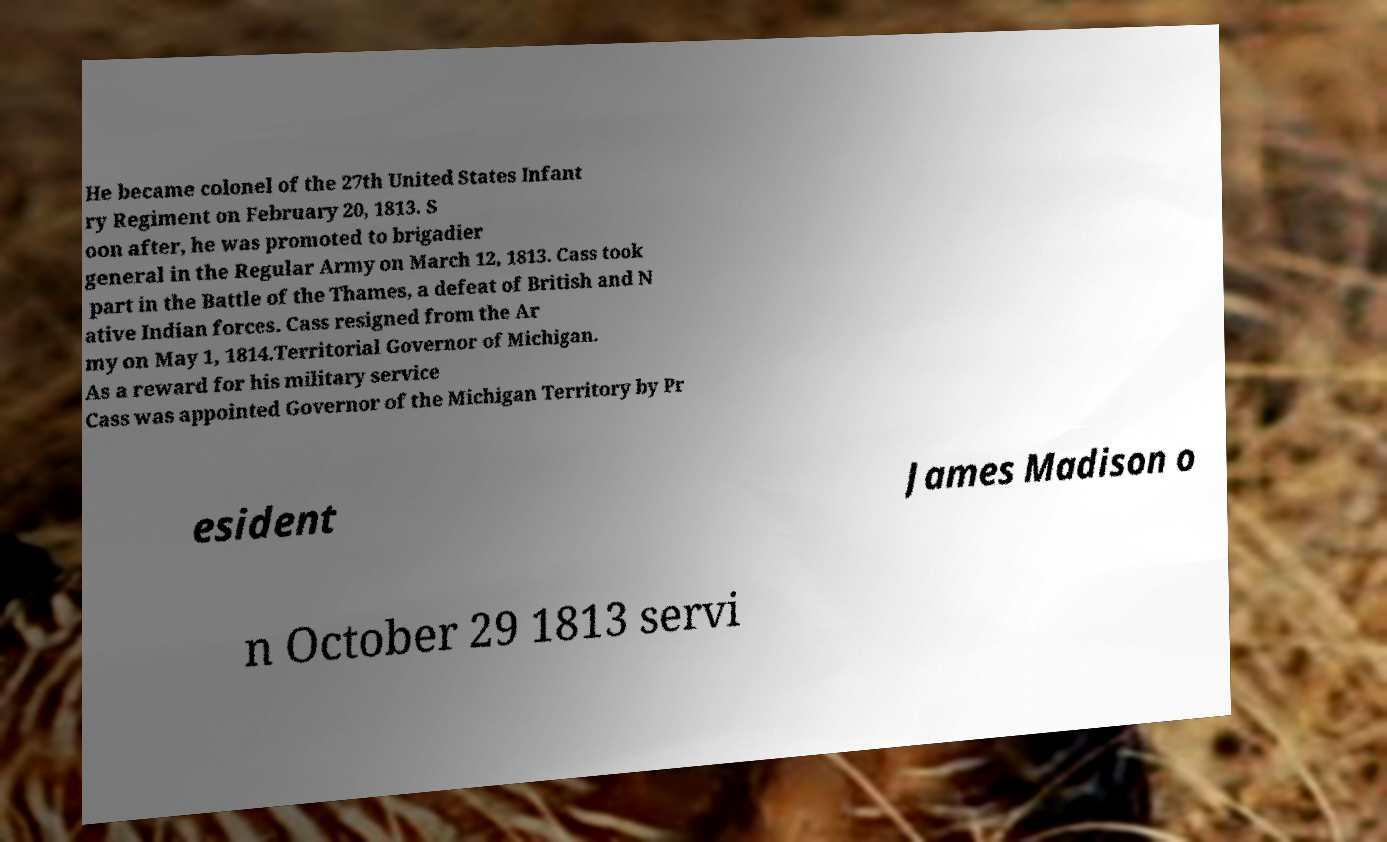I need the written content from this picture converted into text. Can you do that? He became colonel of the 27th United States Infant ry Regiment on February 20, 1813. S oon after, he was promoted to brigadier general in the Regular Army on March 12, 1813. Cass took part in the Battle of the Thames, a defeat of British and N ative Indian forces. Cass resigned from the Ar my on May 1, 1814.Territorial Governor of Michigan. As a reward for his military service Cass was appointed Governor of the Michigan Territory by Pr esident James Madison o n October 29 1813 servi 